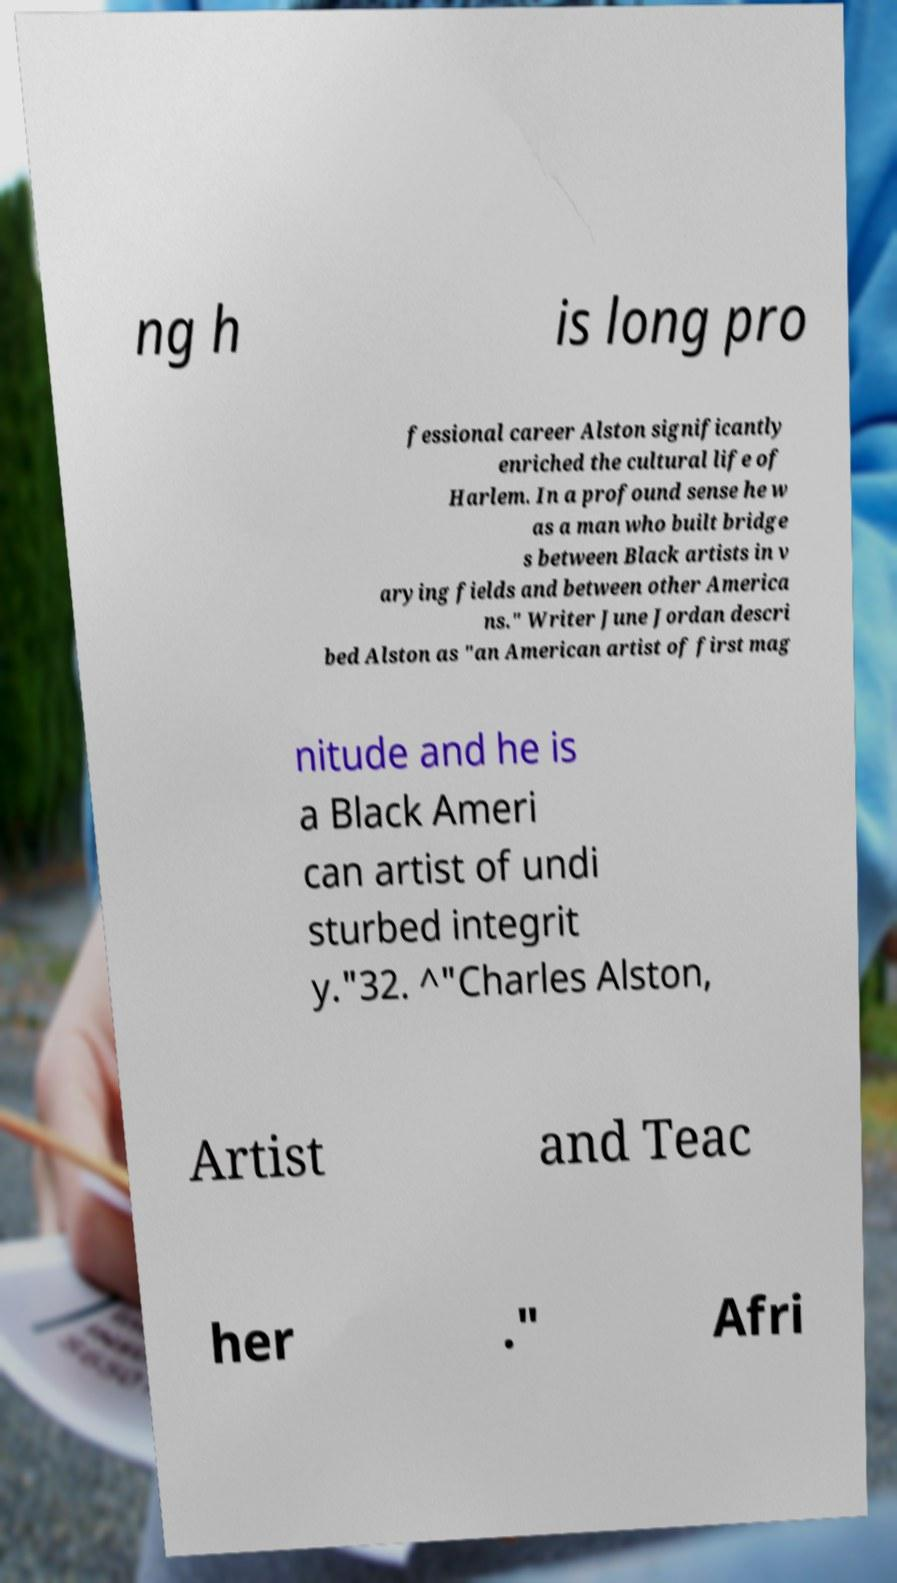Please read and relay the text visible in this image. What does it say? ng h is long pro fessional career Alston significantly enriched the cultural life of Harlem. In a profound sense he w as a man who built bridge s between Black artists in v arying fields and between other America ns." Writer June Jordan descri bed Alston as "an American artist of first mag nitude and he is a Black Ameri can artist of undi sturbed integrit y."32. ^"Charles Alston, Artist and Teac her ." Afri 